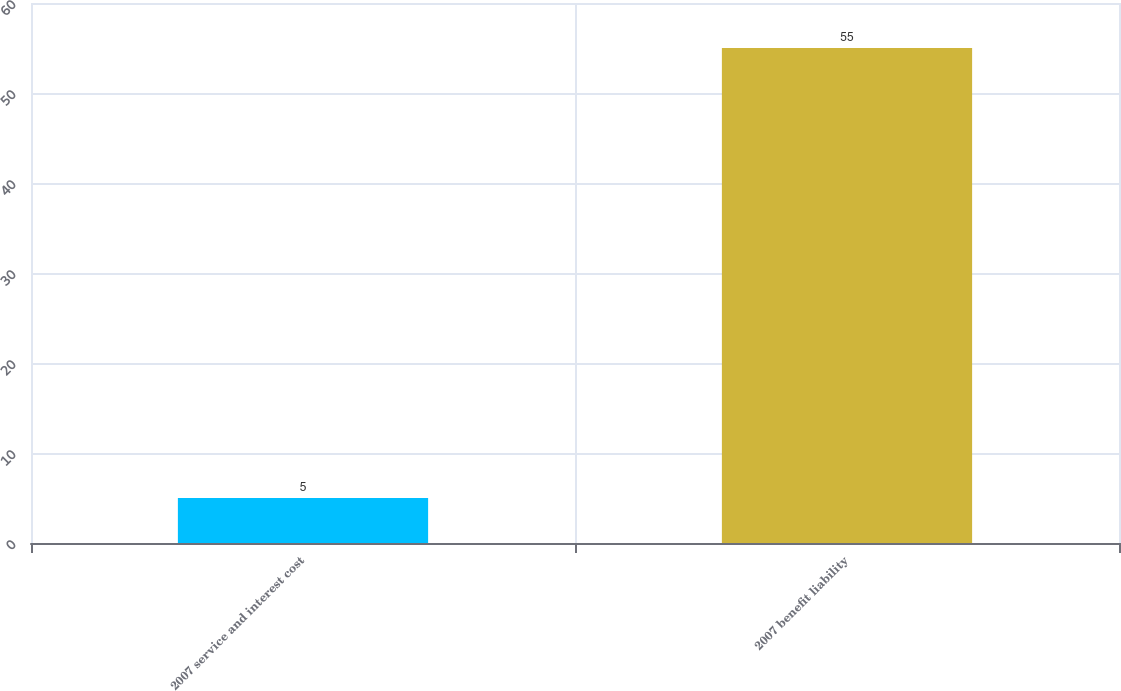Convert chart to OTSL. <chart><loc_0><loc_0><loc_500><loc_500><bar_chart><fcel>2007 service and interest cost<fcel>2007 benefit liability<nl><fcel>5<fcel>55<nl></chart> 